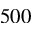<formula> <loc_0><loc_0><loc_500><loc_500>5 0 0</formula> 